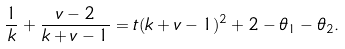<formula> <loc_0><loc_0><loc_500><loc_500>\frac { 1 } { k } + \frac { v - 2 } { k + v - 1 } = t ( k + v - 1 ) ^ { 2 } + 2 - \theta _ { 1 } - \theta _ { 2 } .</formula> 